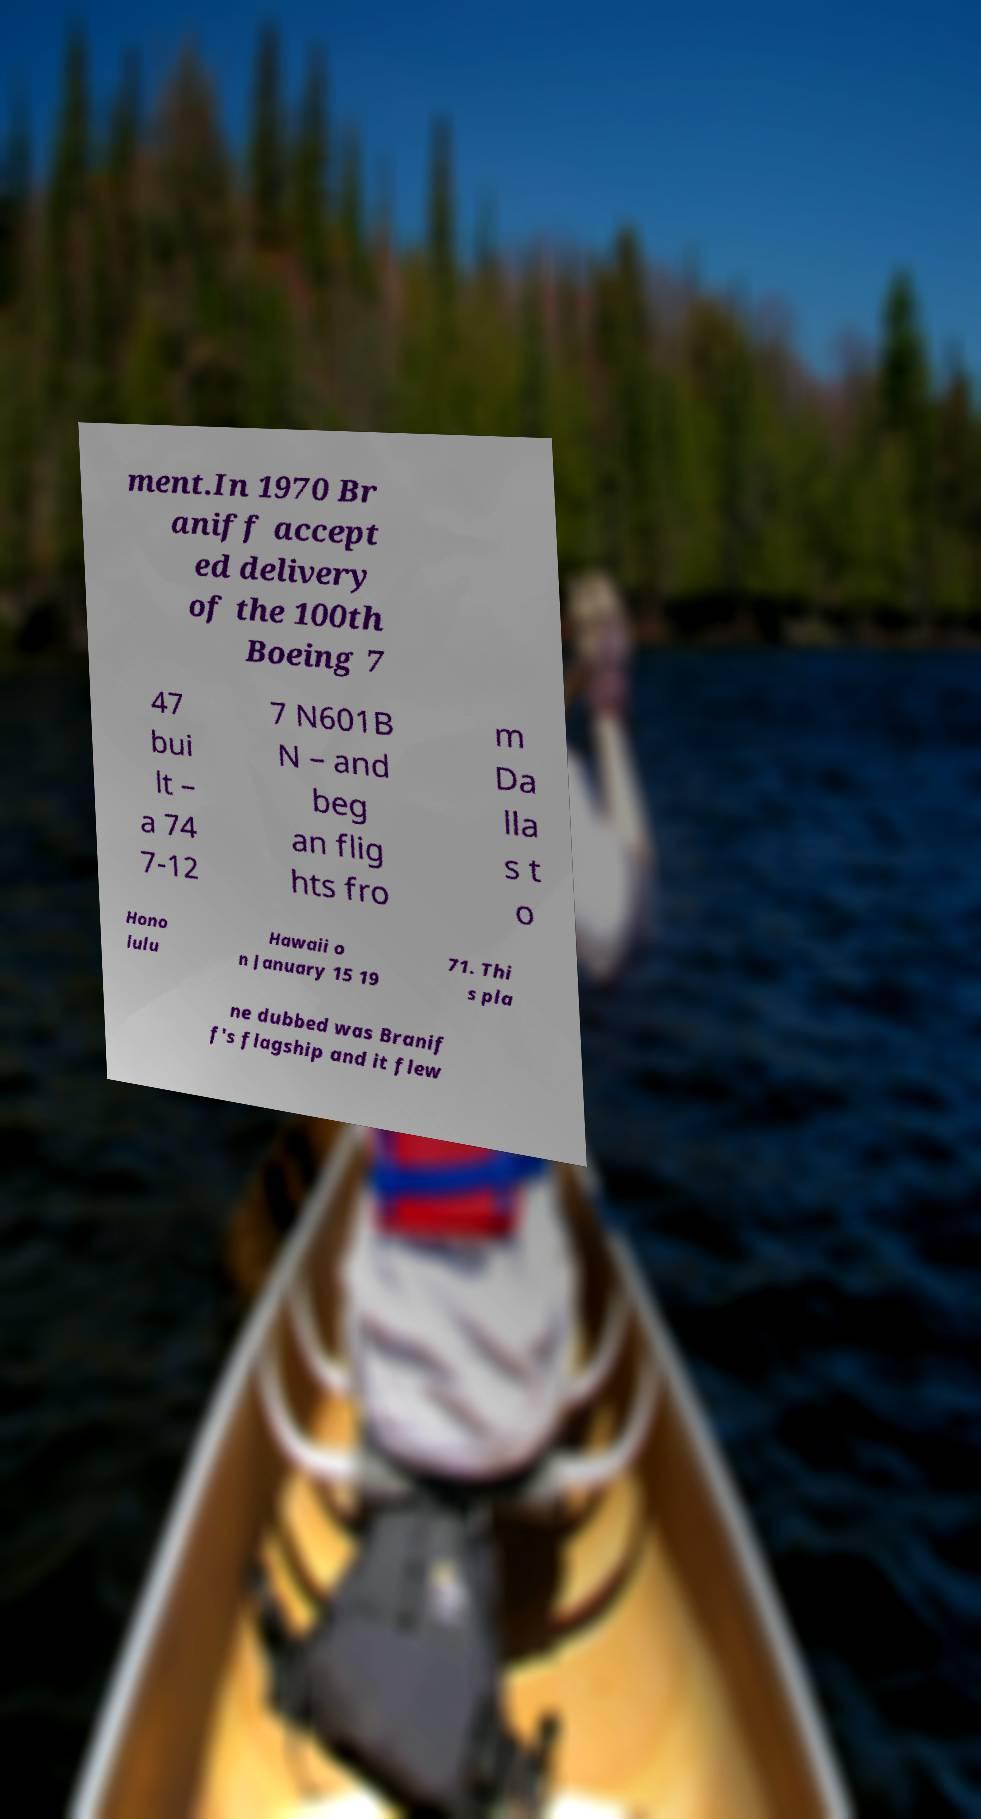Could you extract and type out the text from this image? ment.In 1970 Br aniff accept ed delivery of the 100th Boeing 7 47 bui lt – a 74 7-12 7 N601B N – and beg an flig hts fro m Da lla s t o Hono lulu Hawaii o n January 15 19 71. Thi s pla ne dubbed was Branif f's flagship and it flew 